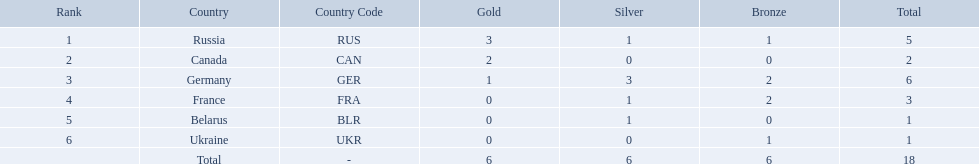What are all the countries in the 1994 winter olympics biathlon? Russia (RUS), Canada (CAN), Germany (GER), France (FRA), Belarus (BLR), Ukraine (UKR). Which of these received at least one gold medal? Russia (RUS), Canada (CAN), Germany (GER). Which of these received no silver or bronze medals? Canada (CAN). 